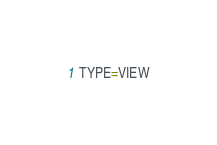Convert code to text. <code><loc_0><loc_0><loc_500><loc_500><_VisualBasic_>TYPE=VIEW</code> 